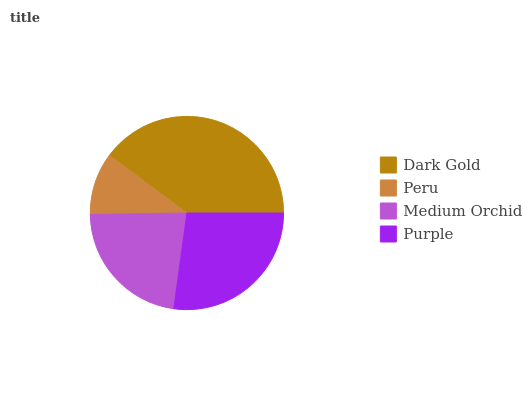Is Peru the minimum?
Answer yes or no. Yes. Is Dark Gold the maximum?
Answer yes or no. Yes. Is Medium Orchid the minimum?
Answer yes or no. No. Is Medium Orchid the maximum?
Answer yes or no. No. Is Medium Orchid greater than Peru?
Answer yes or no. Yes. Is Peru less than Medium Orchid?
Answer yes or no. Yes. Is Peru greater than Medium Orchid?
Answer yes or no. No. Is Medium Orchid less than Peru?
Answer yes or no. No. Is Purple the high median?
Answer yes or no. Yes. Is Medium Orchid the low median?
Answer yes or no. Yes. Is Dark Gold the high median?
Answer yes or no. No. Is Peru the low median?
Answer yes or no. No. 